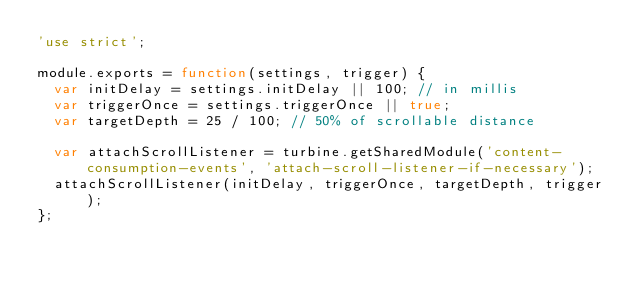Convert code to text. <code><loc_0><loc_0><loc_500><loc_500><_JavaScript_>'use strict';

module.exports = function(settings, trigger) {
  var initDelay = settings.initDelay || 100; // in millis
  var triggerOnce = settings.triggerOnce || true;
  var targetDepth = 25 / 100; // 50% of scrollable distance

  var attachScrollListener = turbine.getSharedModule('content-consumption-events', 'attach-scroll-listener-if-necessary');
  attachScrollListener(initDelay, triggerOnce, targetDepth, trigger);
};
</code> 